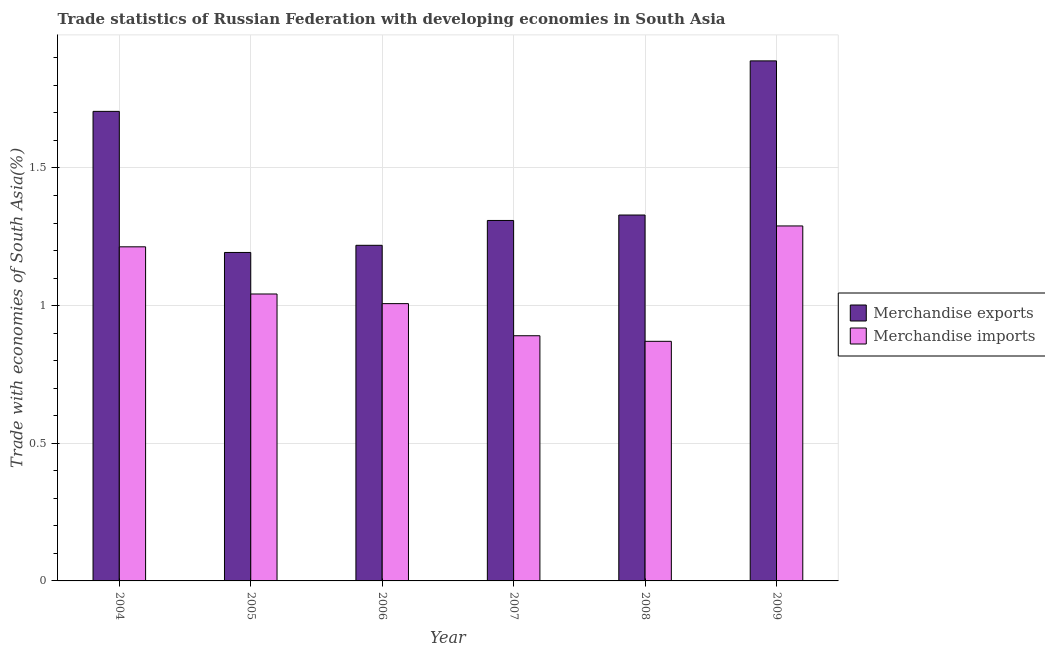How many different coloured bars are there?
Provide a short and direct response. 2. Are the number of bars per tick equal to the number of legend labels?
Offer a very short reply. Yes. Are the number of bars on each tick of the X-axis equal?
Provide a succinct answer. Yes. In how many cases, is the number of bars for a given year not equal to the number of legend labels?
Ensure brevity in your answer.  0. What is the merchandise imports in 2009?
Provide a succinct answer. 1.29. Across all years, what is the maximum merchandise imports?
Make the answer very short. 1.29. Across all years, what is the minimum merchandise exports?
Give a very brief answer. 1.19. In which year was the merchandise imports maximum?
Your answer should be compact. 2009. What is the total merchandise exports in the graph?
Give a very brief answer. 8.65. What is the difference between the merchandise exports in 2004 and that in 2007?
Give a very brief answer. 0.4. What is the difference between the merchandise imports in 2004 and the merchandise exports in 2009?
Offer a terse response. -0.08. What is the average merchandise exports per year?
Your response must be concise. 1.44. What is the ratio of the merchandise imports in 2004 to that in 2007?
Keep it short and to the point. 1.36. What is the difference between the highest and the second highest merchandise exports?
Ensure brevity in your answer.  0.18. What is the difference between the highest and the lowest merchandise exports?
Offer a very short reply. 0.7. Is the sum of the merchandise imports in 2004 and 2008 greater than the maximum merchandise exports across all years?
Offer a very short reply. Yes. What does the 1st bar from the left in 2007 represents?
Offer a very short reply. Merchandise exports. What does the 2nd bar from the right in 2006 represents?
Offer a terse response. Merchandise exports. What is the difference between two consecutive major ticks on the Y-axis?
Your answer should be compact. 0.5. Are the values on the major ticks of Y-axis written in scientific E-notation?
Your answer should be compact. No. Does the graph contain grids?
Offer a terse response. Yes. How many legend labels are there?
Your answer should be compact. 2. How are the legend labels stacked?
Provide a succinct answer. Vertical. What is the title of the graph?
Keep it short and to the point. Trade statistics of Russian Federation with developing economies in South Asia. Does "Current education expenditure" appear as one of the legend labels in the graph?
Your answer should be compact. No. What is the label or title of the X-axis?
Your answer should be very brief. Year. What is the label or title of the Y-axis?
Give a very brief answer. Trade with economies of South Asia(%). What is the Trade with economies of South Asia(%) in Merchandise exports in 2004?
Give a very brief answer. 1.71. What is the Trade with economies of South Asia(%) in Merchandise imports in 2004?
Your answer should be very brief. 1.21. What is the Trade with economies of South Asia(%) in Merchandise exports in 2005?
Your response must be concise. 1.19. What is the Trade with economies of South Asia(%) in Merchandise imports in 2005?
Offer a very short reply. 1.04. What is the Trade with economies of South Asia(%) in Merchandise exports in 2006?
Your answer should be very brief. 1.22. What is the Trade with economies of South Asia(%) in Merchandise imports in 2006?
Your answer should be very brief. 1.01. What is the Trade with economies of South Asia(%) of Merchandise exports in 2007?
Provide a short and direct response. 1.31. What is the Trade with economies of South Asia(%) of Merchandise imports in 2007?
Ensure brevity in your answer.  0.89. What is the Trade with economies of South Asia(%) in Merchandise exports in 2008?
Keep it short and to the point. 1.33. What is the Trade with economies of South Asia(%) of Merchandise imports in 2008?
Offer a terse response. 0.87. What is the Trade with economies of South Asia(%) in Merchandise exports in 2009?
Keep it short and to the point. 1.89. What is the Trade with economies of South Asia(%) in Merchandise imports in 2009?
Provide a succinct answer. 1.29. Across all years, what is the maximum Trade with economies of South Asia(%) in Merchandise exports?
Ensure brevity in your answer.  1.89. Across all years, what is the maximum Trade with economies of South Asia(%) of Merchandise imports?
Provide a succinct answer. 1.29. Across all years, what is the minimum Trade with economies of South Asia(%) in Merchandise exports?
Your answer should be compact. 1.19. Across all years, what is the minimum Trade with economies of South Asia(%) of Merchandise imports?
Provide a succinct answer. 0.87. What is the total Trade with economies of South Asia(%) in Merchandise exports in the graph?
Give a very brief answer. 8.65. What is the total Trade with economies of South Asia(%) of Merchandise imports in the graph?
Make the answer very short. 6.31. What is the difference between the Trade with economies of South Asia(%) in Merchandise exports in 2004 and that in 2005?
Your answer should be very brief. 0.51. What is the difference between the Trade with economies of South Asia(%) of Merchandise imports in 2004 and that in 2005?
Offer a very short reply. 0.17. What is the difference between the Trade with economies of South Asia(%) of Merchandise exports in 2004 and that in 2006?
Provide a succinct answer. 0.49. What is the difference between the Trade with economies of South Asia(%) in Merchandise imports in 2004 and that in 2006?
Provide a short and direct response. 0.21. What is the difference between the Trade with economies of South Asia(%) in Merchandise exports in 2004 and that in 2007?
Offer a very short reply. 0.4. What is the difference between the Trade with economies of South Asia(%) of Merchandise imports in 2004 and that in 2007?
Provide a succinct answer. 0.32. What is the difference between the Trade with economies of South Asia(%) in Merchandise exports in 2004 and that in 2008?
Make the answer very short. 0.38. What is the difference between the Trade with economies of South Asia(%) of Merchandise imports in 2004 and that in 2008?
Give a very brief answer. 0.34. What is the difference between the Trade with economies of South Asia(%) of Merchandise exports in 2004 and that in 2009?
Provide a succinct answer. -0.18. What is the difference between the Trade with economies of South Asia(%) of Merchandise imports in 2004 and that in 2009?
Your answer should be compact. -0.08. What is the difference between the Trade with economies of South Asia(%) in Merchandise exports in 2005 and that in 2006?
Provide a short and direct response. -0.03. What is the difference between the Trade with economies of South Asia(%) in Merchandise imports in 2005 and that in 2006?
Your answer should be very brief. 0.04. What is the difference between the Trade with economies of South Asia(%) in Merchandise exports in 2005 and that in 2007?
Provide a short and direct response. -0.12. What is the difference between the Trade with economies of South Asia(%) of Merchandise imports in 2005 and that in 2007?
Your answer should be very brief. 0.15. What is the difference between the Trade with economies of South Asia(%) in Merchandise exports in 2005 and that in 2008?
Provide a short and direct response. -0.14. What is the difference between the Trade with economies of South Asia(%) in Merchandise imports in 2005 and that in 2008?
Make the answer very short. 0.17. What is the difference between the Trade with economies of South Asia(%) of Merchandise exports in 2005 and that in 2009?
Offer a very short reply. -0.7. What is the difference between the Trade with economies of South Asia(%) of Merchandise imports in 2005 and that in 2009?
Offer a very short reply. -0.25. What is the difference between the Trade with economies of South Asia(%) of Merchandise exports in 2006 and that in 2007?
Offer a very short reply. -0.09. What is the difference between the Trade with economies of South Asia(%) in Merchandise imports in 2006 and that in 2007?
Provide a succinct answer. 0.12. What is the difference between the Trade with economies of South Asia(%) of Merchandise exports in 2006 and that in 2008?
Offer a terse response. -0.11. What is the difference between the Trade with economies of South Asia(%) of Merchandise imports in 2006 and that in 2008?
Your response must be concise. 0.14. What is the difference between the Trade with economies of South Asia(%) in Merchandise exports in 2006 and that in 2009?
Your response must be concise. -0.67. What is the difference between the Trade with economies of South Asia(%) in Merchandise imports in 2006 and that in 2009?
Give a very brief answer. -0.28. What is the difference between the Trade with economies of South Asia(%) in Merchandise exports in 2007 and that in 2008?
Your answer should be very brief. -0.02. What is the difference between the Trade with economies of South Asia(%) of Merchandise imports in 2007 and that in 2008?
Provide a short and direct response. 0.02. What is the difference between the Trade with economies of South Asia(%) of Merchandise exports in 2007 and that in 2009?
Keep it short and to the point. -0.58. What is the difference between the Trade with economies of South Asia(%) of Merchandise imports in 2007 and that in 2009?
Your response must be concise. -0.4. What is the difference between the Trade with economies of South Asia(%) in Merchandise exports in 2008 and that in 2009?
Offer a very short reply. -0.56. What is the difference between the Trade with economies of South Asia(%) of Merchandise imports in 2008 and that in 2009?
Your answer should be very brief. -0.42. What is the difference between the Trade with economies of South Asia(%) in Merchandise exports in 2004 and the Trade with economies of South Asia(%) in Merchandise imports in 2005?
Your response must be concise. 0.66. What is the difference between the Trade with economies of South Asia(%) in Merchandise exports in 2004 and the Trade with economies of South Asia(%) in Merchandise imports in 2006?
Offer a very short reply. 0.7. What is the difference between the Trade with economies of South Asia(%) in Merchandise exports in 2004 and the Trade with economies of South Asia(%) in Merchandise imports in 2007?
Offer a terse response. 0.82. What is the difference between the Trade with economies of South Asia(%) in Merchandise exports in 2004 and the Trade with economies of South Asia(%) in Merchandise imports in 2008?
Offer a terse response. 0.84. What is the difference between the Trade with economies of South Asia(%) of Merchandise exports in 2004 and the Trade with economies of South Asia(%) of Merchandise imports in 2009?
Provide a succinct answer. 0.42. What is the difference between the Trade with economies of South Asia(%) in Merchandise exports in 2005 and the Trade with economies of South Asia(%) in Merchandise imports in 2006?
Your response must be concise. 0.19. What is the difference between the Trade with economies of South Asia(%) of Merchandise exports in 2005 and the Trade with economies of South Asia(%) of Merchandise imports in 2007?
Offer a very short reply. 0.3. What is the difference between the Trade with economies of South Asia(%) in Merchandise exports in 2005 and the Trade with economies of South Asia(%) in Merchandise imports in 2008?
Give a very brief answer. 0.32. What is the difference between the Trade with economies of South Asia(%) of Merchandise exports in 2005 and the Trade with economies of South Asia(%) of Merchandise imports in 2009?
Ensure brevity in your answer.  -0.1. What is the difference between the Trade with economies of South Asia(%) in Merchandise exports in 2006 and the Trade with economies of South Asia(%) in Merchandise imports in 2007?
Offer a terse response. 0.33. What is the difference between the Trade with economies of South Asia(%) in Merchandise exports in 2006 and the Trade with economies of South Asia(%) in Merchandise imports in 2008?
Your answer should be very brief. 0.35. What is the difference between the Trade with economies of South Asia(%) in Merchandise exports in 2006 and the Trade with economies of South Asia(%) in Merchandise imports in 2009?
Keep it short and to the point. -0.07. What is the difference between the Trade with economies of South Asia(%) in Merchandise exports in 2007 and the Trade with economies of South Asia(%) in Merchandise imports in 2008?
Offer a very short reply. 0.44. What is the difference between the Trade with economies of South Asia(%) of Merchandise exports in 2007 and the Trade with economies of South Asia(%) of Merchandise imports in 2009?
Offer a terse response. 0.02. What is the difference between the Trade with economies of South Asia(%) in Merchandise exports in 2008 and the Trade with economies of South Asia(%) in Merchandise imports in 2009?
Offer a terse response. 0.04. What is the average Trade with economies of South Asia(%) in Merchandise exports per year?
Make the answer very short. 1.44. What is the average Trade with economies of South Asia(%) in Merchandise imports per year?
Offer a terse response. 1.05. In the year 2004, what is the difference between the Trade with economies of South Asia(%) in Merchandise exports and Trade with economies of South Asia(%) in Merchandise imports?
Your answer should be very brief. 0.49. In the year 2005, what is the difference between the Trade with economies of South Asia(%) of Merchandise exports and Trade with economies of South Asia(%) of Merchandise imports?
Offer a terse response. 0.15. In the year 2006, what is the difference between the Trade with economies of South Asia(%) in Merchandise exports and Trade with economies of South Asia(%) in Merchandise imports?
Provide a succinct answer. 0.21. In the year 2007, what is the difference between the Trade with economies of South Asia(%) of Merchandise exports and Trade with economies of South Asia(%) of Merchandise imports?
Ensure brevity in your answer.  0.42. In the year 2008, what is the difference between the Trade with economies of South Asia(%) in Merchandise exports and Trade with economies of South Asia(%) in Merchandise imports?
Make the answer very short. 0.46. In the year 2009, what is the difference between the Trade with economies of South Asia(%) of Merchandise exports and Trade with economies of South Asia(%) of Merchandise imports?
Give a very brief answer. 0.6. What is the ratio of the Trade with economies of South Asia(%) in Merchandise exports in 2004 to that in 2005?
Keep it short and to the point. 1.43. What is the ratio of the Trade with economies of South Asia(%) in Merchandise imports in 2004 to that in 2005?
Your answer should be compact. 1.16. What is the ratio of the Trade with economies of South Asia(%) in Merchandise exports in 2004 to that in 2006?
Make the answer very short. 1.4. What is the ratio of the Trade with economies of South Asia(%) of Merchandise imports in 2004 to that in 2006?
Ensure brevity in your answer.  1.2. What is the ratio of the Trade with economies of South Asia(%) of Merchandise exports in 2004 to that in 2007?
Offer a terse response. 1.3. What is the ratio of the Trade with economies of South Asia(%) in Merchandise imports in 2004 to that in 2007?
Keep it short and to the point. 1.36. What is the ratio of the Trade with economies of South Asia(%) in Merchandise exports in 2004 to that in 2008?
Provide a short and direct response. 1.28. What is the ratio of the Trade with economies of South Asia(%) of Merchandise imports in 2004 to that in 2008?
Your answer should be compact. 1.39. What is the ratio of the Trade with economies of South Asia(%) of Merchandise exports in 2004 to that in 2009?
Give a very brief answer. 0.9. What is the ratio of the Trade with economies of South Asia(%) in Merchandise exports in 2005 to that in 2006?
Provide a short and direct response. 0.98. What is the ratio of the Trade with economies of South Asia(%) in Merchandise imports in 2005 to that in 2006?
Provide a short and direct response. 1.03. What is the ratio of the Trade with economies of South Asia(%) of Merchandise exports in 2005 to that in 2007?
Offer a terse response. 0.91. What is the ratio of the Trade with economies of South Asia(%) of Merchandise imports in 2005 to that in 2007?
Offer a very short reply. 1.17. What is the ratio of the Trade with economies of South Asia(%) in Merchandise exports in 2005 to that in 2008?
Provide a short and direct response. 0.9. What is the ratio of the Trade with economies of South Asia(%) in Merchandise imports in 2005 to that in 2008?
Make the answer very short. 1.2. What is the ratio of the Trade with economies of South Asia(%) in Merchandise exports in 2005 to that in 2009?
Keep it short and to the point. 0.63. What is the ratio of the Trade with economies of South Asia(%) in Merchandise imports in 2005 to that in 2009?
Your response must be concise. 0.81. What is the ratio of the Trade with economies of South Asia(%) in Merchandise exports in 2006 to that in 2007?
Keep it short and to the point. 0.93. What is the ratio of the Trade with economies of South Asia(%) in Merchandise imports in 2006 to that in 2007?
Make the answer very short. 1.13. What is the ratio of the Trade with economies of South Asia(%) of Merchandise exports in 2006 to that in 2008?
Provide a short and direct response. 0.92. What is the ratio of the Trade with economies of South Asia(%) in Merchandise imports in 2006 to that in 2008?
Ensure brevity in your answer.  1.16. What is the ratio of the Trade with economies of South Asia(%) in Merchandise exports in 2006 to that in 2009?
Your answer should be compact. 0.65. What is the ratio of the Trade with economies of South Asia(%) in Merchandise imports in 2006 to that in 2009?
Keep it short and to the point. 0.78. What is the ratio of the Trade with economies of South Asia(%) in Merchandise exports in 2007 to that in 2008?
Ensure brevity in your answer.  0.99. What is the ratio of the Trade with economies of South Asia(%) in Merchandise imports in 2007 to that in 2008?
Your response must be concise. 1.02. What is the ratio of the Trade with economies of South Asia(%) in Merchandise exports in 2007 to that in 2009?
Ensure brevity in your answer.  0.69. What is the ratio of the Trade with economies of South Asia(%) in Merchandise imports in 2007 to that in 2009?
Ensure brevity in your answer.  0.69. What is the ratio of the Trade with economies of South Asia(%) in Merchandise exports in 2008 to that in 2009?
Offer a very short reply. 0.7. What is the ratio of the Trade with economies of South Asia(%) in Merchandise imports in 2008 to that in 2009?
Your answer should be very brief. 0.68. What is the difference between the highest and the second highest Trade with economies of South Asia(%) of Merchandise exports?
Offer a very short reply. 0.18. What is the difference between the highest and the second highest Trade with economies of South Asia(%) of Merchandise imports?
Provide a short and direct response. 0.08. What is the difference between the highest and the lowest Trade with economies of South Asia(%) of Merchandise exports?
Ensure brevity in your answer.  0.7. What is the difference between the highest and the lowest Trade with economies of South Asia(%) in Merchandise imports?
Your answer should be very brief. 0.42. 